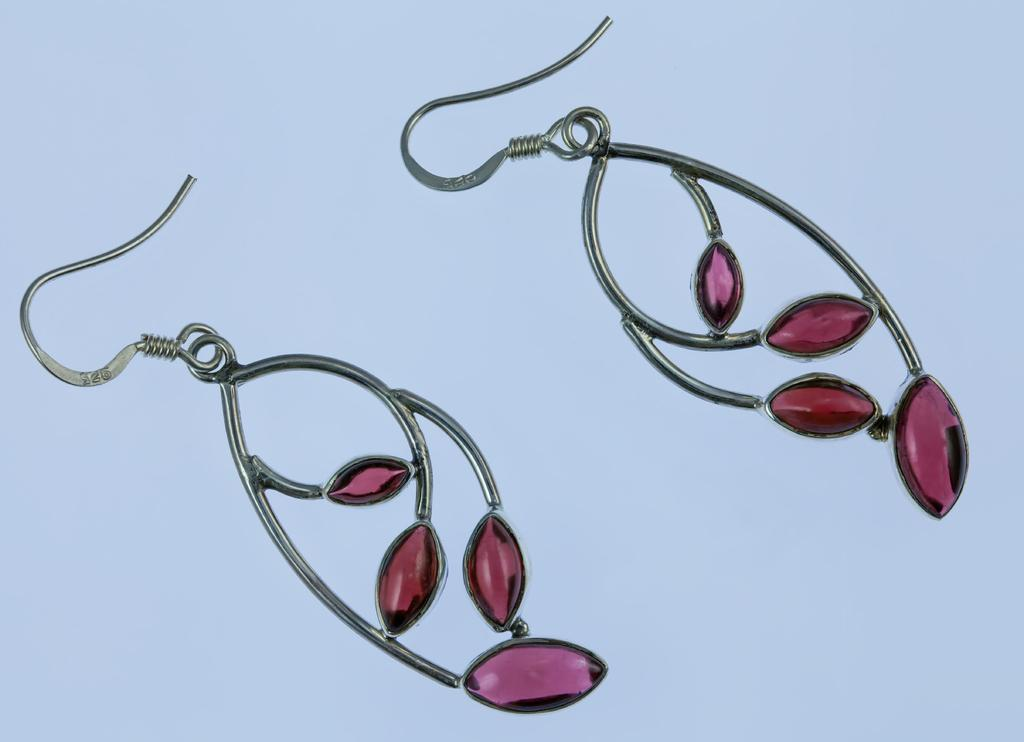What type of accessory is present in the image? There are earrings in the image. How many cherries are hanging from the earrings in the image? There are no cherries present in the image, as it only features earrings. 